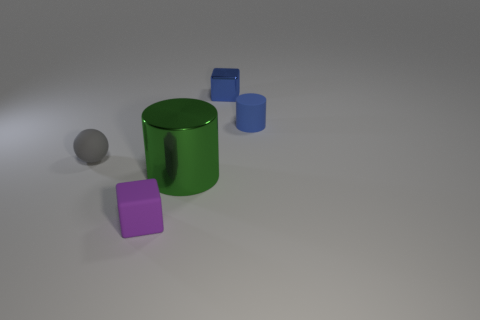Can you tell me what time of day it might be based on the lighting in the image? Given the neutral and diffuse quality of light present in the image, suggesting an absence of distinct shadows or highlights, it is not indicative of any particular time of day. It's more likely that the lighting is artificial, designed to evenly illuminate the objects in a controlled environment. 